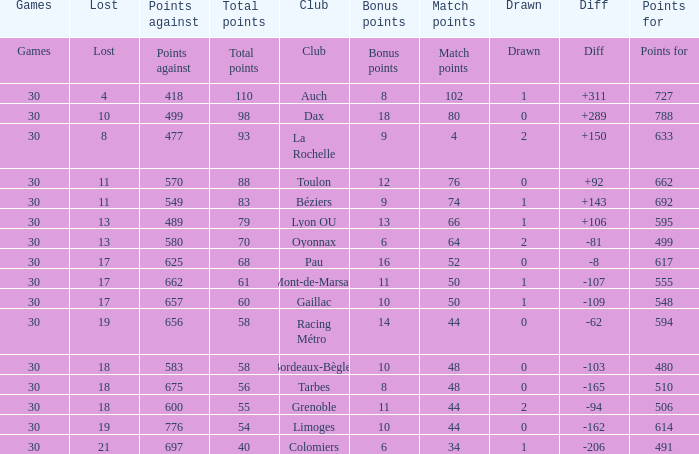How many bonus points did the Colomiers earn? 6.0. Could you help me parse every detail presented in this table? {'header': ['Games', 'Lost', 'Points against', 'Total points', 'Club', 'Bonus points', 'Match points', 'Drawn', 'Diff', 'Points for'], 'rows': [['Games', 'Lost', 'Points against', 'Total points', 'Club', 'Bonus points', 'Match points', 'Drawn', 'Diff', 'Points for'], ['30', '4', '418', '110', 'Auch', '8', '102', '1', '+311', '727'], ['30', '10', '499', '98', 'Dax', '18', '80', '0', '+289', '788'], ['30', '8', '477', '93', 'La Rochelle', '9', '4', '2', '+150', '633'], ['30', '11', '570', '88', 'Toulon', '12', '76', '0', '+92', '662'], ['30', '11', '549', '83', 'Béziers', '9', '74', '1', '+143', '692'], ['30', '13', '489', '79', 'Lyon OU', '13', '66', '1', '+106', '595'], ['30', '13', '580', '70', 'Oyonnax', '6', '64', '2', '-81', '499'], ['30', '17', '625', '68', 'Pau', '16', '52', '0', '-8', '617'], ['30', '17', '662', '61', 'Mont-de-Marsan', '11', '50', '1', '-107', '555'], ['30', '17', '657', '60', 'Gaillac', '10', '50', '1', '-109', '548'], ['30', '19', '656', '58', 'Racing Métro', '14', '44', '0', '-62', '594'], ['30', '18', '583', '58', 'Bordeaux-Bègles', '10', '48', '0', '-103', '480'], ['30', '18', '675', '56', 'Tarbes', '8', '48', '0', '-165', '510'], ['30', '18', '600', '55', 'Grenoble', '11', '44', '2', '-94', '506'], ['30', '19', '776', '54', 'Limoges', '10', '44', '0', '-162', '614'], ['30', '21', '697', '40', 'Colomiers', '6', '34', '1', '-206', '491']]} 